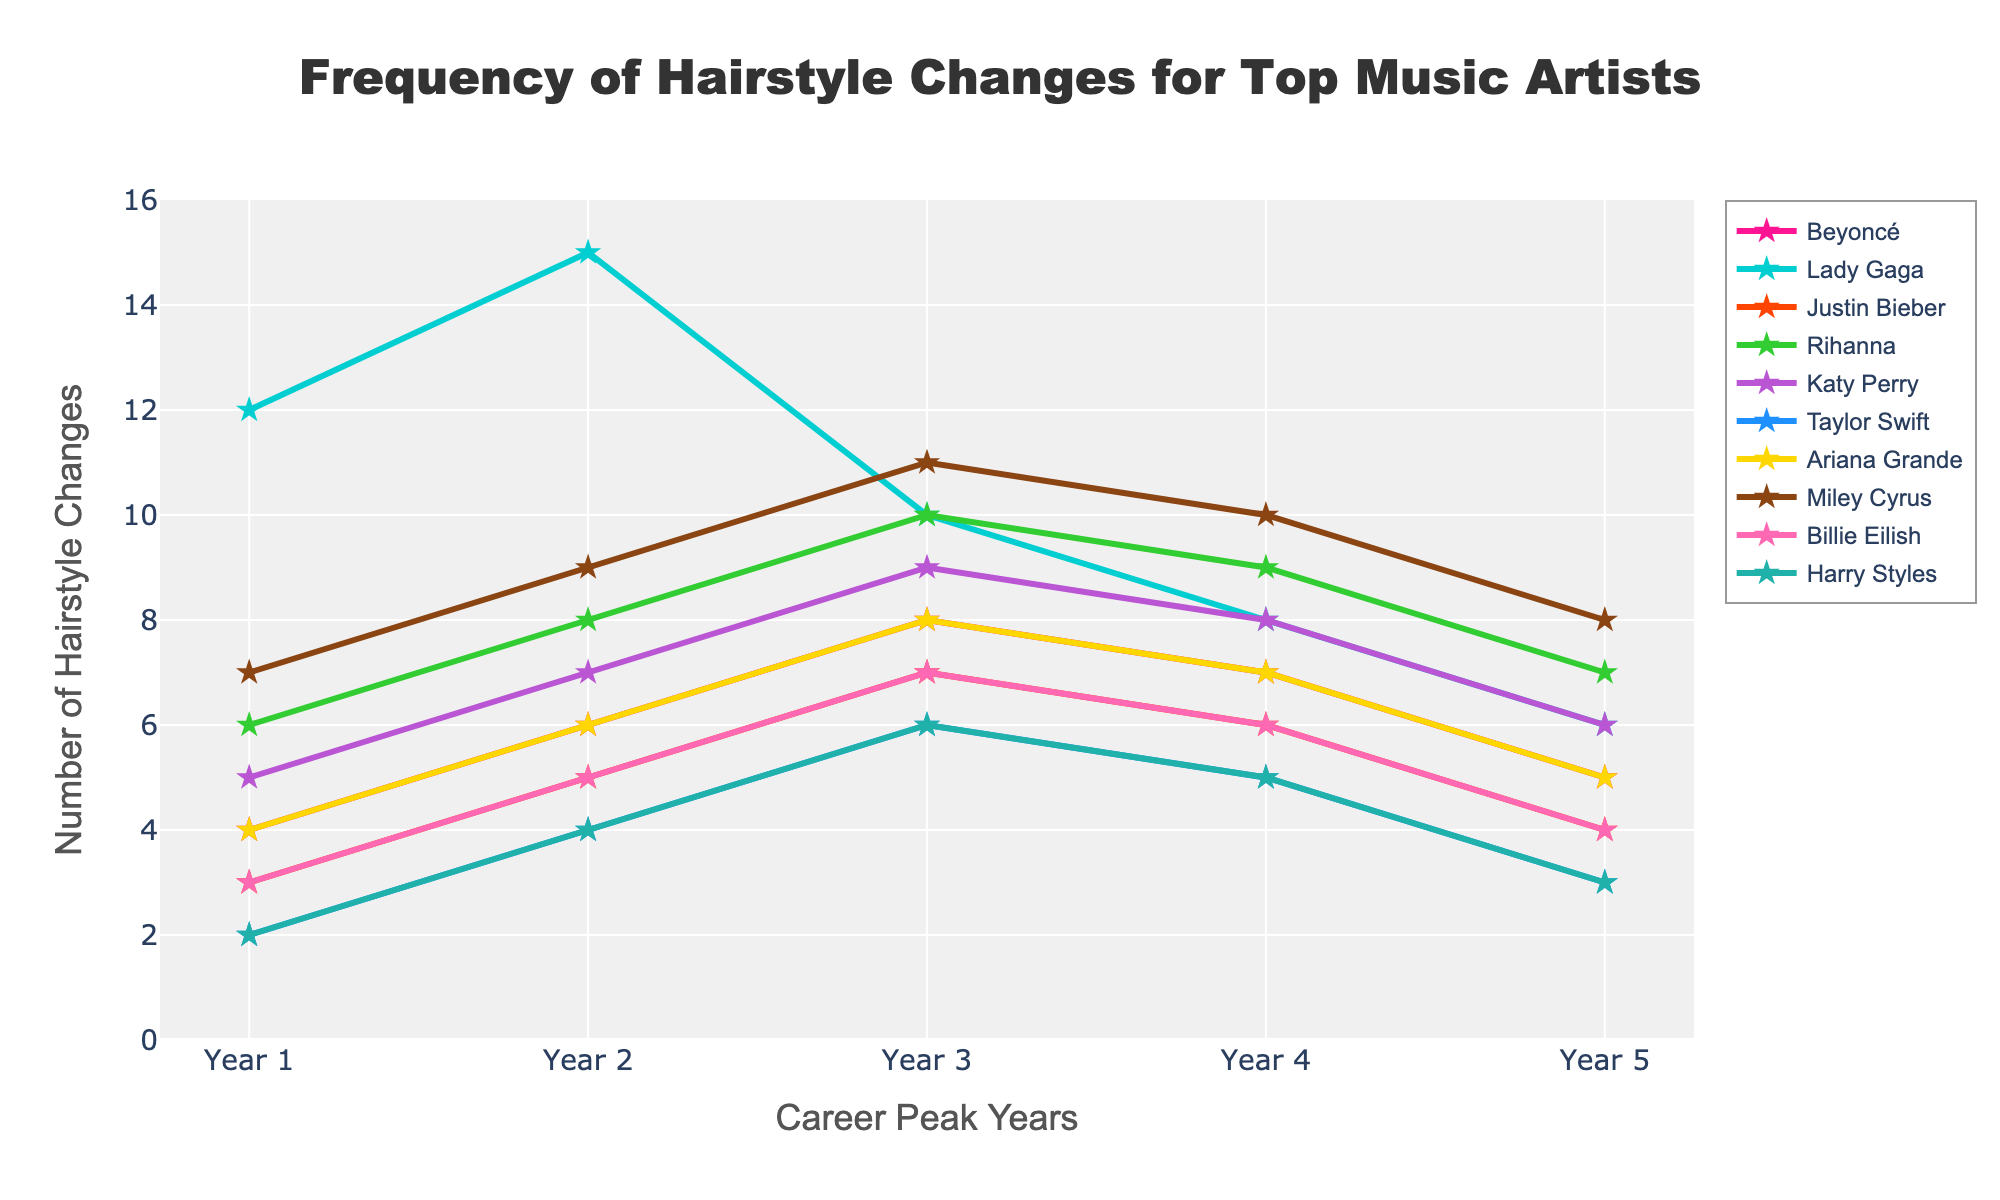Which artist has the highest frequency of hairstyle changes in any given year? Lady Gaga's frequency peaks at 15 in Year 2. By looking at the plot, Lady Gaga's curve reaches the highest point in Year 2.
Answer: Lady Gaga Which artist shows the most consistent frequency of hairstyle changes over the five years? Beyoncé and Ariana Grande both have almost similar fluctuations, but the deviations in their graphs are not as steep compared to others. Both rise in Year 1 and then slightly decrease in the later years identified by symmetrical frequency trends.
Answer: Beyoncé and Ariana Grande Whose hairstyle change frequency decreases the most from their peak to the end of the period? Lady Gaga's frequency drops from 15 in Year 2 to 6 in Year 5, which is the largest decrease. By observing the chart, Lady Gaga's line shows the steepest decline from its peak in Year 2.
Answer: Lady Gaga What is the average frequency of hairstyle changes for Katy Perry over the five years? Adding frequencies 5, 7, 9, 8, 6 gives 35. The average is 35/5 = 7. This involves summing up the values and dividing by the number of years.
Answer: 7 How does Taylor Swift's frequency of hairstyle changes compare to Justin Bieber's in Year 3? In Year 3, Taylor Swift's frequency is 6 while Justin Bieber's is 7. By comparing the two values in Year 3 from the plot.
Answer: Taylor Swift has lower frequency than Justin Bieber Which years do Miley Cyrus and Rihanna have the exact same frequency of hairstyle changes? In both Years 2 and 4, Miley Cyrus and Rihanna have the same frequency: 9 and 10 respectively. The lines for Miley Cyrus and Rihanna intersect at these frequencies in those years.
Answer: Year 2 and Year 4 Which artist has a similar frequency trend to Miley Cyrus but with lower overall values? Rihanna's trend mimics Miley Cyrus's but at a lower level overall. Both show similar shapes - an increase, stabilization, and then decline.
Answer: Rihanna What is the combined frequency of hairstyle changes for Beyoncé and Ariana Grande in Year 4? Beyoncé has 7 and Ariana Grande has 7 in Year 4, so the combined frequency is 14. Summing these two values from the chart gives the combined frequency.
Answer: 14 Between Years 2 and 3, who shows the steepest decrease in hairstyle changes? Lady Gaga shows the steepest decrease, dropping from 15 to 10. The plot shows a steep drop in Lady Gaga's line between these years.
Answer: Lady Gaga 